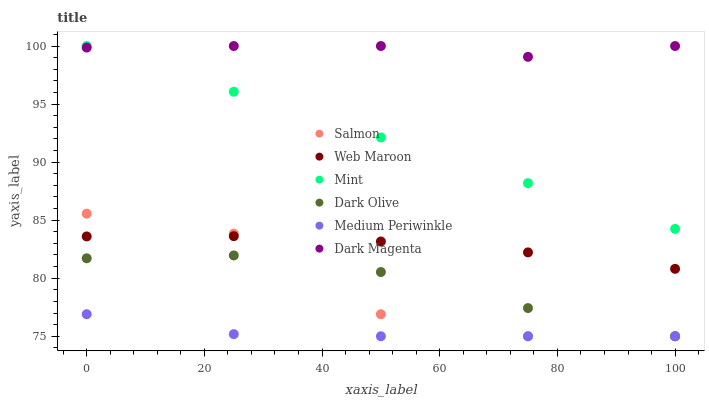Does Medium Periwinkle have the minimum area under the curve?
Answer yes or no. Yes. Does Dark Magenta have the maximum area under the curve?
Answer yes or no. Yes. Does Salmon have the minimum area under the curve?
Answer yes or no. No. Does Salmon have the maximum area under the curve?
Answer yes or no. No. Is Mint the smoothest?
Answer yes or no. Yes. Is Salmon the roughest?
Answer yes or no. Yes. Is Medium Periwinkle the smoothest?
Answer yes or no. No. Is Medium Periwinkle the roughest?
Answer yes or no. No. Does Medium Periwinkle have the lowest value?
Answer yes or no. Yes. Does Web Maroon have the lowest value?
Answer yes or no. No. Does Mint have the highest value?
Answer yes or no. Yes. Does Salmon have the highest value?
Answer yes or no. No. Is Dark Olive less than Web Maroon?
Answer yes or no. Yes. Is Dark Magenta greater than Dark Olive?
Answer yes or no. Yes. Does Mint intersect Dark Magenta?
Answer yes or no. Yes. Is Mint less than Dark Magenta?
Answer yes or no. No. Is Mint greater than Dark Magenta?
Answer yes or no. No. Does Dark Olive intersect Web Maroon?
Answer yes or no. No. 